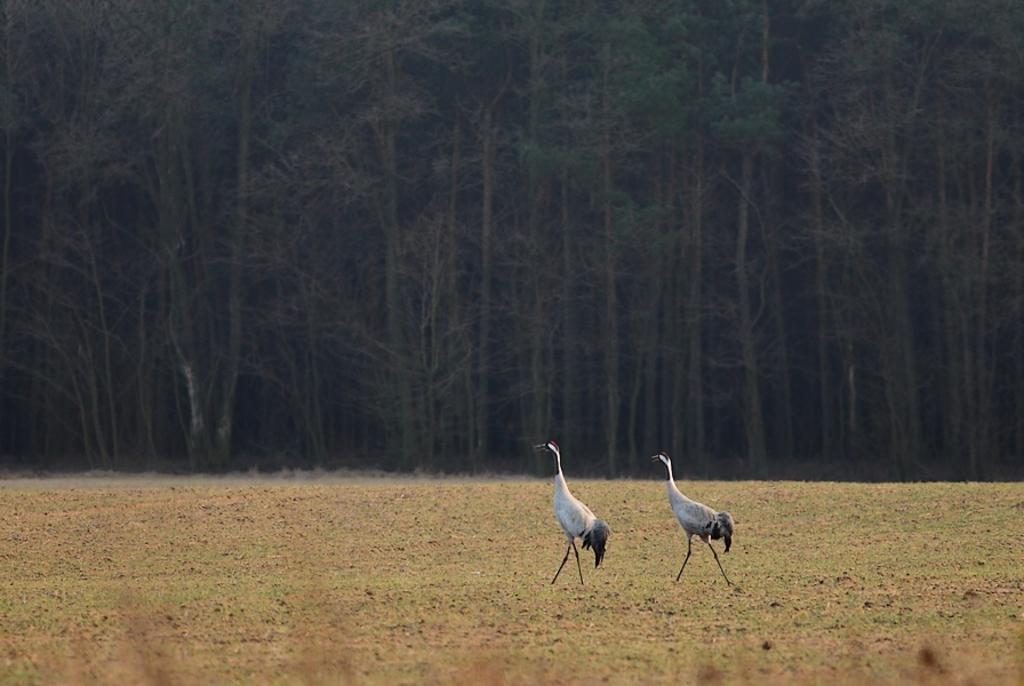How many birds are present in the image? There are two birds in the image. What are the birds doing in the image? The birds are walking. What can be seen in the background of the image? There are trees in the background of the image. What type of credit card is the bird holding in the image? There is no credit card present in the image; the birds are simply walking. 